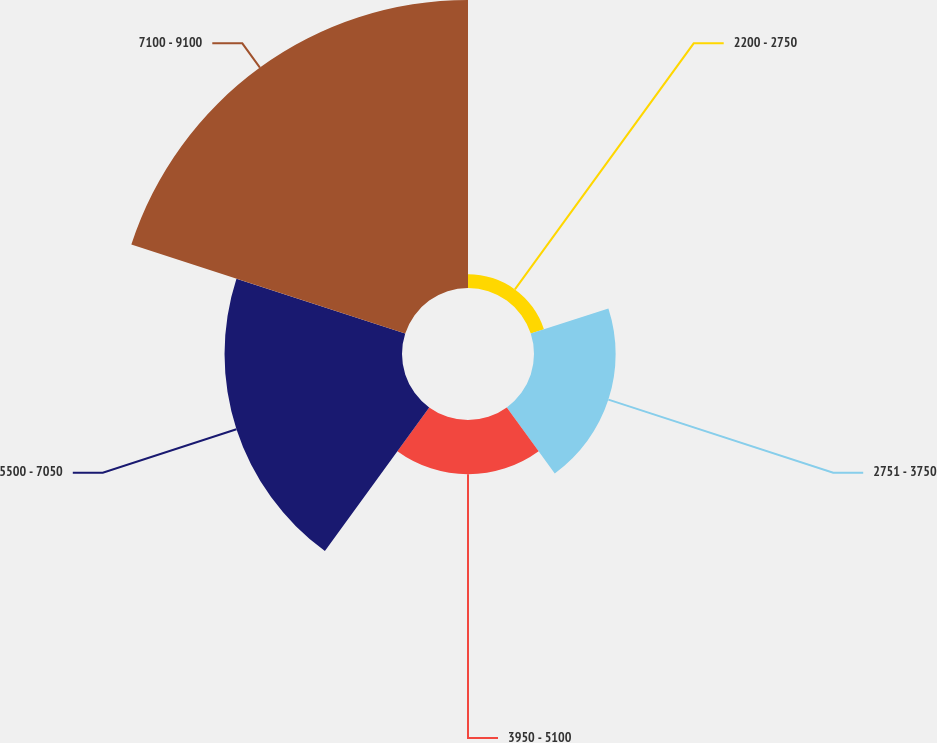<chart> <loc_0><loc_0><loc_500><loc_500><pie_chart><fcel>2200 - 2750<fcel>2751 - 3750<fcel>3950 - 5100<fcel>5500 - 7050<fcel>7100 - 9100<nl><fcel>2.25%<fcel>13.27%<fcel>8.81%<fcel>28.85%<fcel>46.82%<nl></chart> 